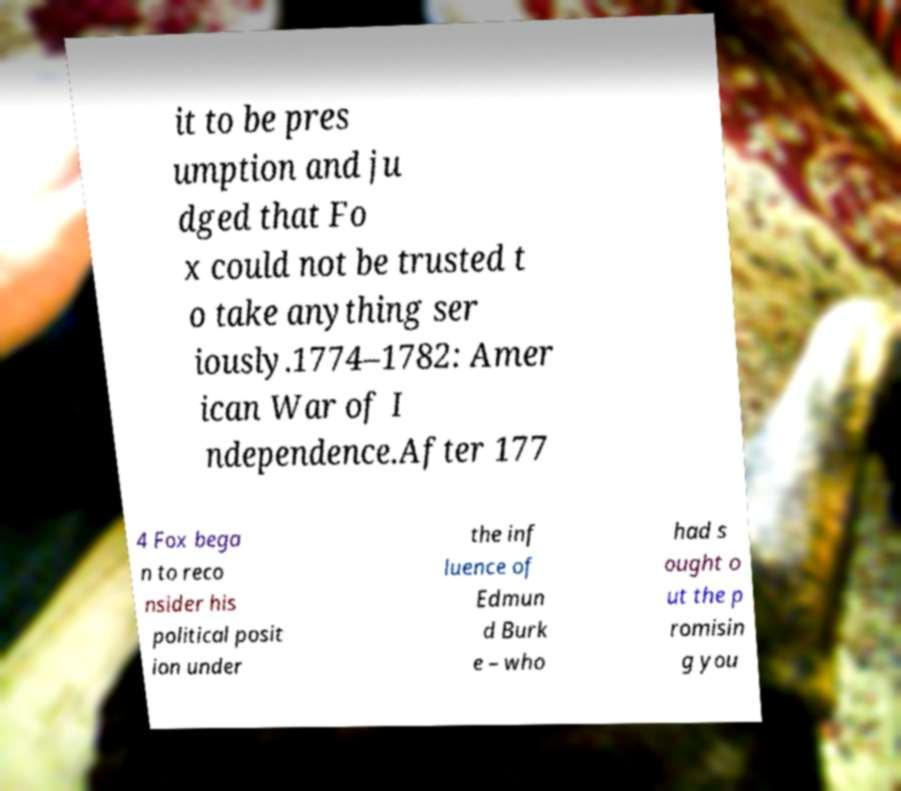Please identify and transcribe the text found in this image. it to be pres umption and ju dged that Fo x could not be trusted t o take anything ser iously.1774–1782: Amer ican War of I ndependence.After 177 4 Fox bega n to reco nsider his political posit ion under the inf luence of Edmun d Burk e – who had s ought o ut the p romisin g you 